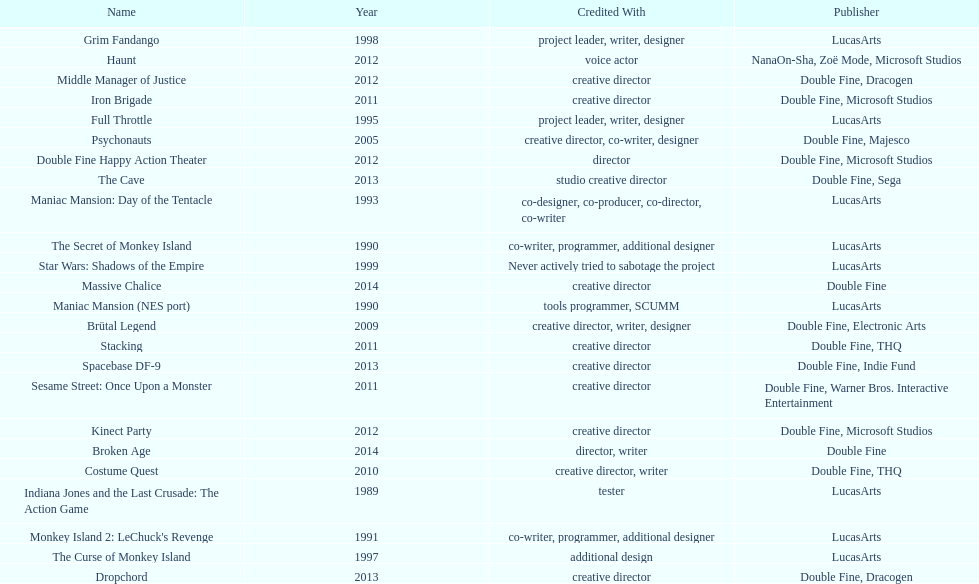Which game is credited with a creative director and warner bros. interactive entertainment as their creative director? Sesame Street: Once Upon a Monster. 